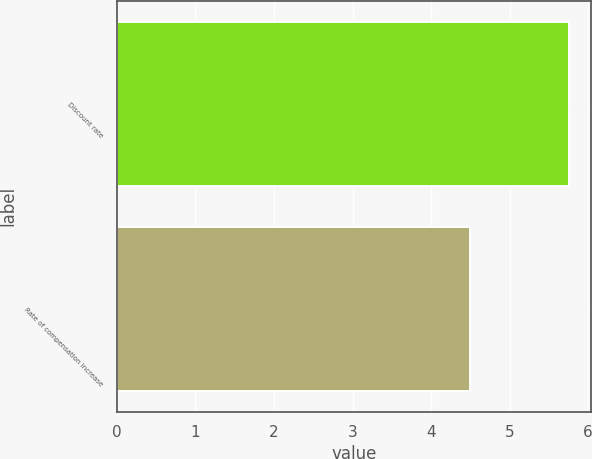Convert chart to OTSL. <chart><loc_0><loc_0><loc_500><loc_500><bar_chart><fcel>Discount rate<fcel>Rate of compensation increase<nl><fcel>5.75<fcel>4.5<nl></chart> 